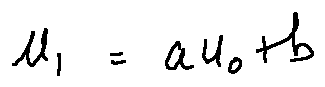Convert formula to latex. <formula><loc_0><loc_0><loc_500><loc_500>u _ { 1 } = a u _ { 0 } + b</formula> 